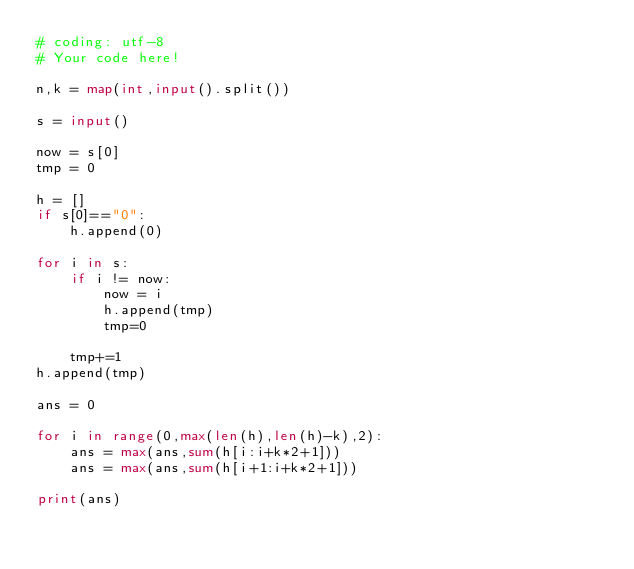Convert code to text. <code><loc_0><loc_0><loc_500><loc_500><_Python_># coding: utf-8
# Your code here!

n,k = map(int,input().split())

s = input()

now = s[0]
tmp = 0

h = []
if s[0]=="0":
    h.append(0)

for i in s:
    if i != now:
        now = i
        h.append(tmp)
        tmp=0
        
    tmp+=1
h.append(tmp)

ans = 0

for i in range(0,max(len(h),len(h)-k),2):
    ans = max(ans,sum(h[i:i+k*2+1]))
    ans = max(ans,sum(h[i+1:i+k*2+1]))

print(ans)</code> 